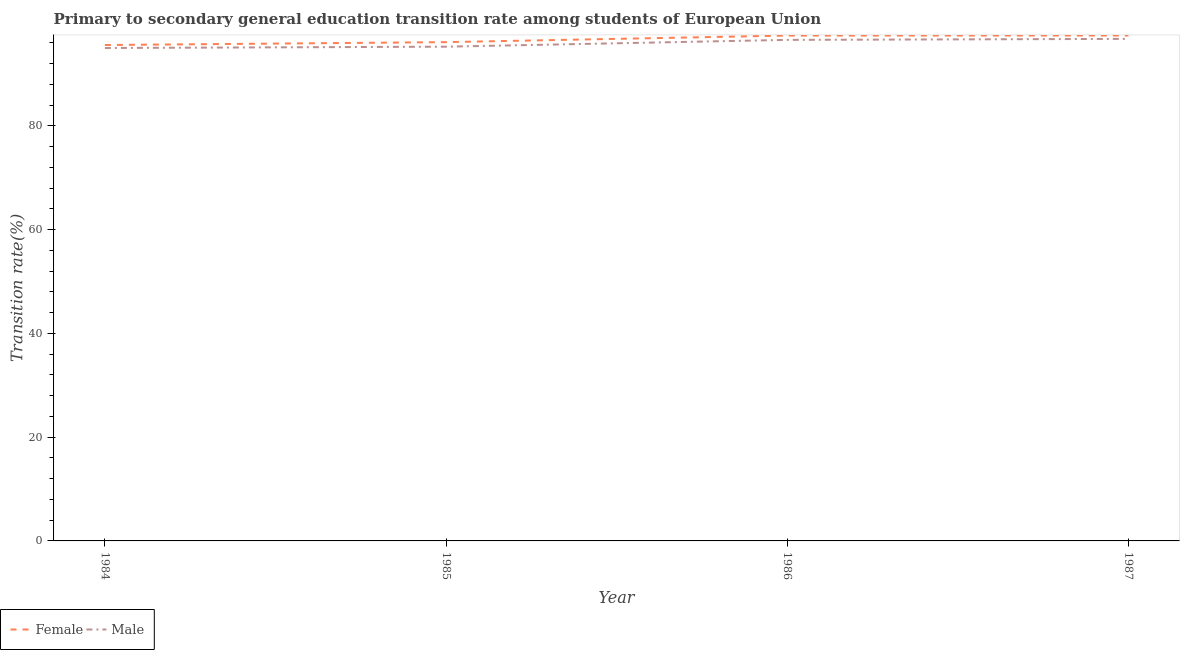How many different coloured lines are there?
Offer a very short reply. 2. Is the number of lines equal to the number of legend labels?
Give a very brief answer. Yes. What is the transition rate among female students in 1986?
Ensure brevity in your answer.  97.43. Across all years, what is the maximum transition rate among male students?
Your answer should be compact. 96.79. Across all years, what is the minimum transition rate among female students?
Your answer should be very brief. 95.61. What is the total transition rate among male students in the graph?
Offer a very short reply. 383.71. What is the difference between the transition rate among female students in 1985 and that in 1986?
Your answer should be compact. -1.27. What is the difference between the transition rate among female students in 1986 and the transition rate among male students in 1985?
Your answer should be very brief. 2.14. What is the average transition rate among female students per year?
Provide a short and direct response. 96.66. In the year 1985, what is the difference between the transition rate among male students and transition rate among female students?
Provide a succinct answer. -0.88. In how many years, is the transition rate among female students greater than 36 %?
Provide a succinct answer. 4. What is the ratio of the transition rate among female students in 1984 to that in 1987?
Keep it short and to the point. 0.98. Is the difference between the transition rate among male students in 1986 and 1987 greater than the difference between the transition rate among female students in 1986 and 1987?
Provide a succinct answer. No. What is the difference between the highest and the second highest transition rate among male students?
Offer a terse response. 0.19. What is the difference between the highest and the lowest transition rate among male students?
Provide a short and direct response. 1.76. Does the transition rate among male students monotonically increase over the years?
Your answer should be very brief. Yes. Is the transition rate among female students strictly less than the transition rate among male students over the years?
Provide a short and direct response. No. How many lines are there?
Your response must be concise. 2. Does the graph contain any zero values?
Your answer should be compact. No. Where does the legend appear in the graph?
Offer a very short reply. Bottom left. How many legend labels are there?
Your response must be concise. 2. How are the legend labels stacked?
Provide a short and direct response. Horizontal. What is the title of the graph?
Your answer should be very brief. Primary to secondary general education transition rate among students of European Union. What is the label or title of the X-axis?
Your answer should be very brief. Year. What is the label or title of the Y-axis?
Offer a very short reply. Transition rate(%). What is the Transition rate(%) in Female in 1984?
Ensure brevity in your answer.  95.61. What is the Transition rate(%) of Male in 1984?
Offer a terse response. 95.03. What is the Transition rate(%) of Female in 1985?
Provide a succinct answer. 96.16. What is the Transition rate(%) in Male in 1985?
Your answer should be compact. 95.29. What is the Transition rate(%) in Female in 1986?
Offer a very short reply. 97.43. What is the Transition rate(%) of Male in 1986?
Provide a succinct answer. 96.6. What is the Transition rate(%) in Female in 1987?
Give a very brief answer. 97.44. What is the Transition rate(%) in Male in 1987?
Keep it short and to the point. 96.79. Across all years, what is the maximum Transition rate(%) in Female?
Give a very brief answer. 97.44. Across all years, what is the maximum Transition rate(%) in Male?
Offer a terse response. 96.79. Across all years, what is the minimum Transition rate(%) of Female?
Your answer should be very brief. 95.61. Across all years, what is the minimum Transition rate(%) of Male?
Offer a very short reply. 95.03. What is the total Transition rate(%) of Female in the graph?
Give a very brief answer. 386.65. What is the total Transition rate(%) in Male in the graph?
Offer a very short reply. 383.71. What is the difference between the Transition rate(%) of Female in 1984 and that in 1985?
Your answer should be compact. -0.55. What is the difference between the Transition rate(%) of Male in 1984 and that in 1985?
Offer a terse response. -0.25. What is the difference between the Transition rate(%) in Female in 1984 and that in 1986?
Make the answer very short. -1.82. What is the difference between the Transition rate(%) in Male in 1984 and that in 1986?
Your response must be concise. -1.57. What is the difference between the Transition rate(%) of Female in 1984 and that in 1987?
Give a very brief answer. -1.83. What is the difference between the Transition rate(%) in Male in 1984 and that in 1987?
Provide a succinct answer. -1.76. What is the difference between the Transition rate(%) of Female in 1985 and that in 1986?
Offer a very short reply. -1.27. What is the difference between the Transition rate(%) in Male in 1985 and that in 1986?
Make the answer very short. -1.31. What is the difference between the Transition rate(%) of Female in 1985 and that in 1987?
Provide a succinct answer. -1.28. What is the difference between the Transition rate(%) of Male in 1985 and that in 1987?
Your response must be concise. -1.5. What is the difference between the Transition rate(%) of Female in 1986 and that in 1987?
Your answer should be compact. -0.01. What is the difference between the Transition rate(%) of Male in 1986 and that in 1987?
Offer a terse response. -0.19. What is the difference between the Transition rate(%) of Female in 1984 and the Transition rate(%) of Male in 1985?
Offer a very short reply. 0.32. What is the difference between the Transition rate(%) in Female in 1984 and the Transition rate(%) in Male in 1986?
Offer a very short reply. -0.99. What is the difference between the Transition rate(%) in Female in 1984 and the Transition rate(%) in Male in 1987?
Your answer should be compact. -1.18. What is the difference between the Transition rate(%) of Female in 1985 and the Transition rate(%) of Male in 1986?
Provide a short and direct response. -0.44. What is the difference between the Transition rate(%) of Female in 1985 and the Transition rate(%) of Male in 1987?
Your answer should be compact. -0.63. What is the difference between the Transition rate(%) of Female in 1986 and the Transition rate(%) of Male in 1987?
Offer a terse response. 0.64. What is the average Transition rate(%) of Female per year?
Give a very brief answer. 96.66. What is the average Transition rate(%) of Male per year?
Ensure brevity in your answer.  95.93. In the year 1984, what is the difference between the Transition rate(%) in Female and Transition rate(%) in Male?
Your answer should be very brief. 0.58. In the year 1985, what is the difference between the Transition rate(%) of Female and Transition rate(%) of Male?
Your response must be concise. 0.88. In the year 1986, what is the difference between the Transition rate(%) in Female and Transition rate(%) in Male?
Ensure brevity in your answer.  0.83. In the year 1987, what is the difference between the Transition rate(%) in Female and Transition rate(%) in Male?
Your answer should be very brief. 0.65. What is the ratio of the Transition rate(%) in Male in 1984 to that in 1985?
Provide a short and direct response. 1. What is the ratio of the Transition rate(%) of Female in 1984 to that in 1986?
Make the answer very short. 0.98. What is the ratio of the Transition rate(%) in Male in 1984 to that in 1986?
Provide a short and direct response. 0.98. What is the ratio of the Transition rate(%) of Female in 1984 to that in 1987?
Your answer should be very brief. 0.98. What is the ratio of the Transition rate(%) of Male in 1984 to that in 1987?
Your answer should be compact. 0.98. What is the ratio of the Transition rate(%) in Female in 1985 to that in 1986?
Ensure brevity in your answer.  0.99. What is the ratio of the Transition rate(%) of Male in 1985 to that in 1986?
Your answer should be compact. 0.99. What is the ratio of the Transition rate(%) in Female in 1985 to that in 1987?
Ensure brevity in your answer.  0.99. What is the ratio of the Transition rate(%) in Male in 1985 to that in 1987?
Your response must be concise. 0.98. What is the ratio of the Transition rate(%) in Male in 1986 to that in 1987?
Offer a terse response. 1. What is the difference between the highest and the second highest Transition rate(%) of Female?
Your response must be concise. 0.01. What is the difference between the highest and the second highest Transition rate(%) in Male?
Your response must be concise. 0.19. What is the difference between the highest and the lowest Transition rate(%) of Female?
Give a very brief answer. 1.83. What is the difference between the highest and the lowest Transition rate(%) of Male?
Offer a terse response. 1.76. 